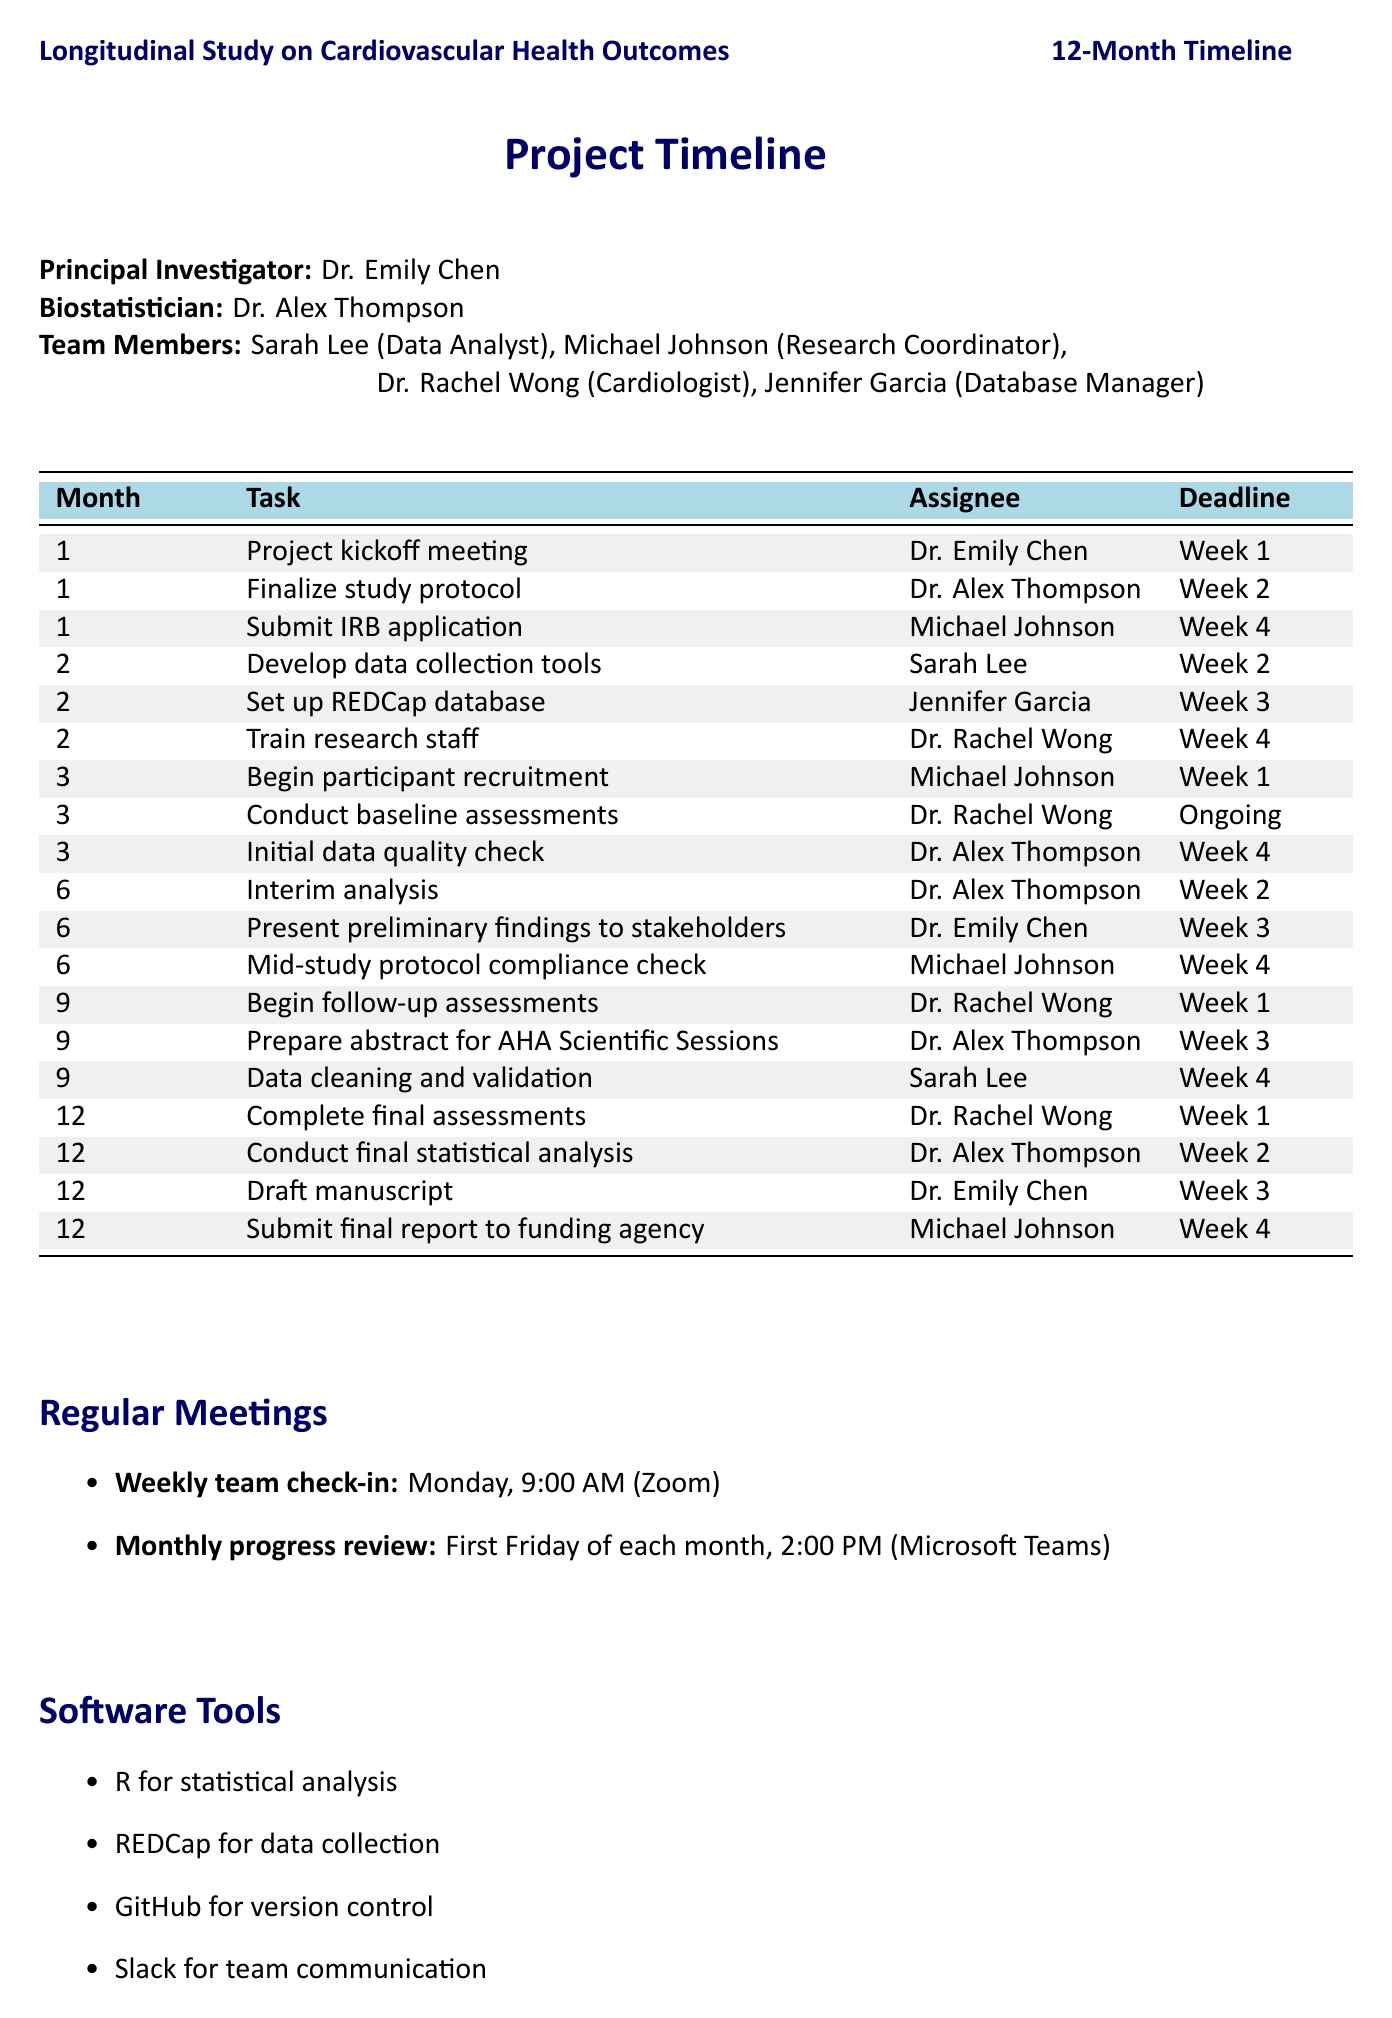What is the principal investigator's name? The principal investigator's name is mentioned in the document as Dr. Emily Chen.
Answer: Dr. Emily Chen In which month is the interim analysis scheduled? The interim analysis is mentioned as a task scheduled in month 6.
Answer: Month 6 Who is responsible for the initial data quality check? The document details that the initial data quality check is assigned to Dr. Alex Thompson.
Answer: Dr. Alex Thompson When is the final report due to the funding agency? The final report submission to the funding agency is scheduled for week 4 of month 12.
Answer: Week 4 What software tool is used for statistical analysis? The document indicates that R is used for statistical analysis.
Answer: R How many team members are there in total? The total number of team members listed in the document, including the principal investigator and biostatistician, is five.
Answer: Five What is the frequency of the weekly team check-in? The document specifies that the weekly team check-in occurs every Monday.
Answer: Monday Which team member is scheduled to draft the manuscript? The draft manuscript task is assigned to Dr. Emily Chen in month 12.
Answer: Dr. Emily Chen What is the deadline for developing data collection tools? The deadline for developing data collection tools is set for week 2 of month 2.
Answer: Week 2 